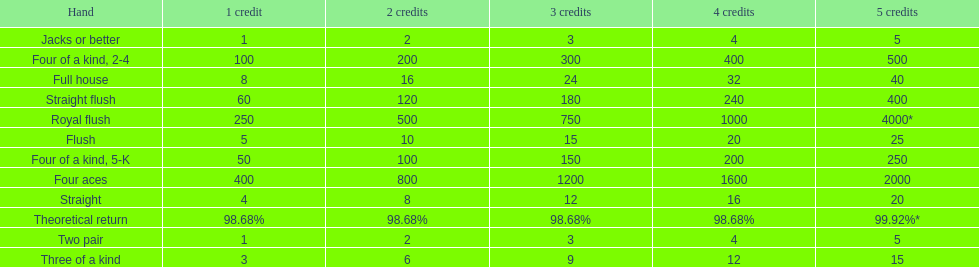The number of flush wins at one credit to equal one flush win at 5 credits. 5. Write the full table. {'header': ['Hand', '1 credit', '2 credits', '3 credits', '4 credits', '5 credits'], 'rows': [['Jacks or better', '1', '2', '3', '4', '5'], ['Four of a kind, 2-4', '100', '200', '300', '400', '500'], ['Full house', '8', '16', '24', '32', '40'], ['Straight flush', '60', '120', '180', '240', '400'], ['Royal flush', '250', '500', '750', '1000', '4000*'], ['Flush', '5', '10', '15', '20', '25'], ['Four of a kind, 5-K', '50', '100', '150', '200', '250'], ['Four aces', '400', '800', '1200', '1600', '2000'], ['Straight', '4', '8', '12', '16', '20'], ['Theoretical return', '98.68%', '98.68%', '98.68%', '98.68%', '99.92%*'], ['Two pair', '1', '2', '3', '4', '5'], ['Three of a kind', '3', '6', '9', '12', '15']]} 